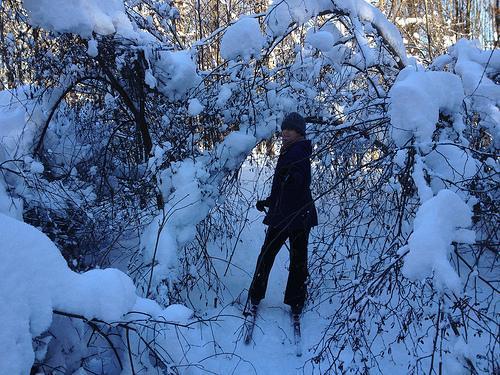How many people are shown?
Give a very brief answer. 1. 